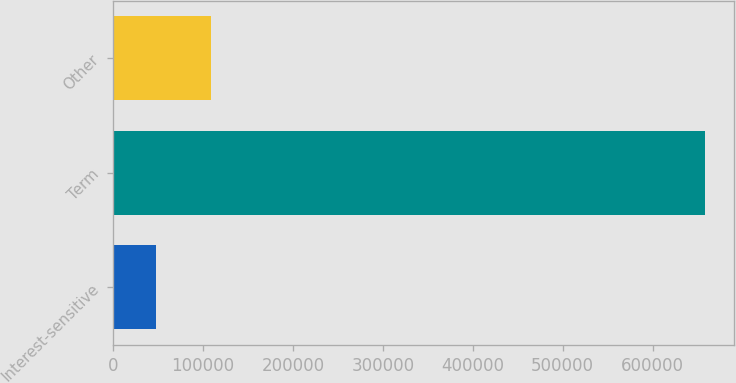Convert chart. <chart><loc_0><loc_0><loc_500><loc_500><bar_chart><fcel>Interest-sensitive<fcel>Term<fcel>Other<nl><fcel>47358<fcel>657797<fcel>108402<nl></chart> 